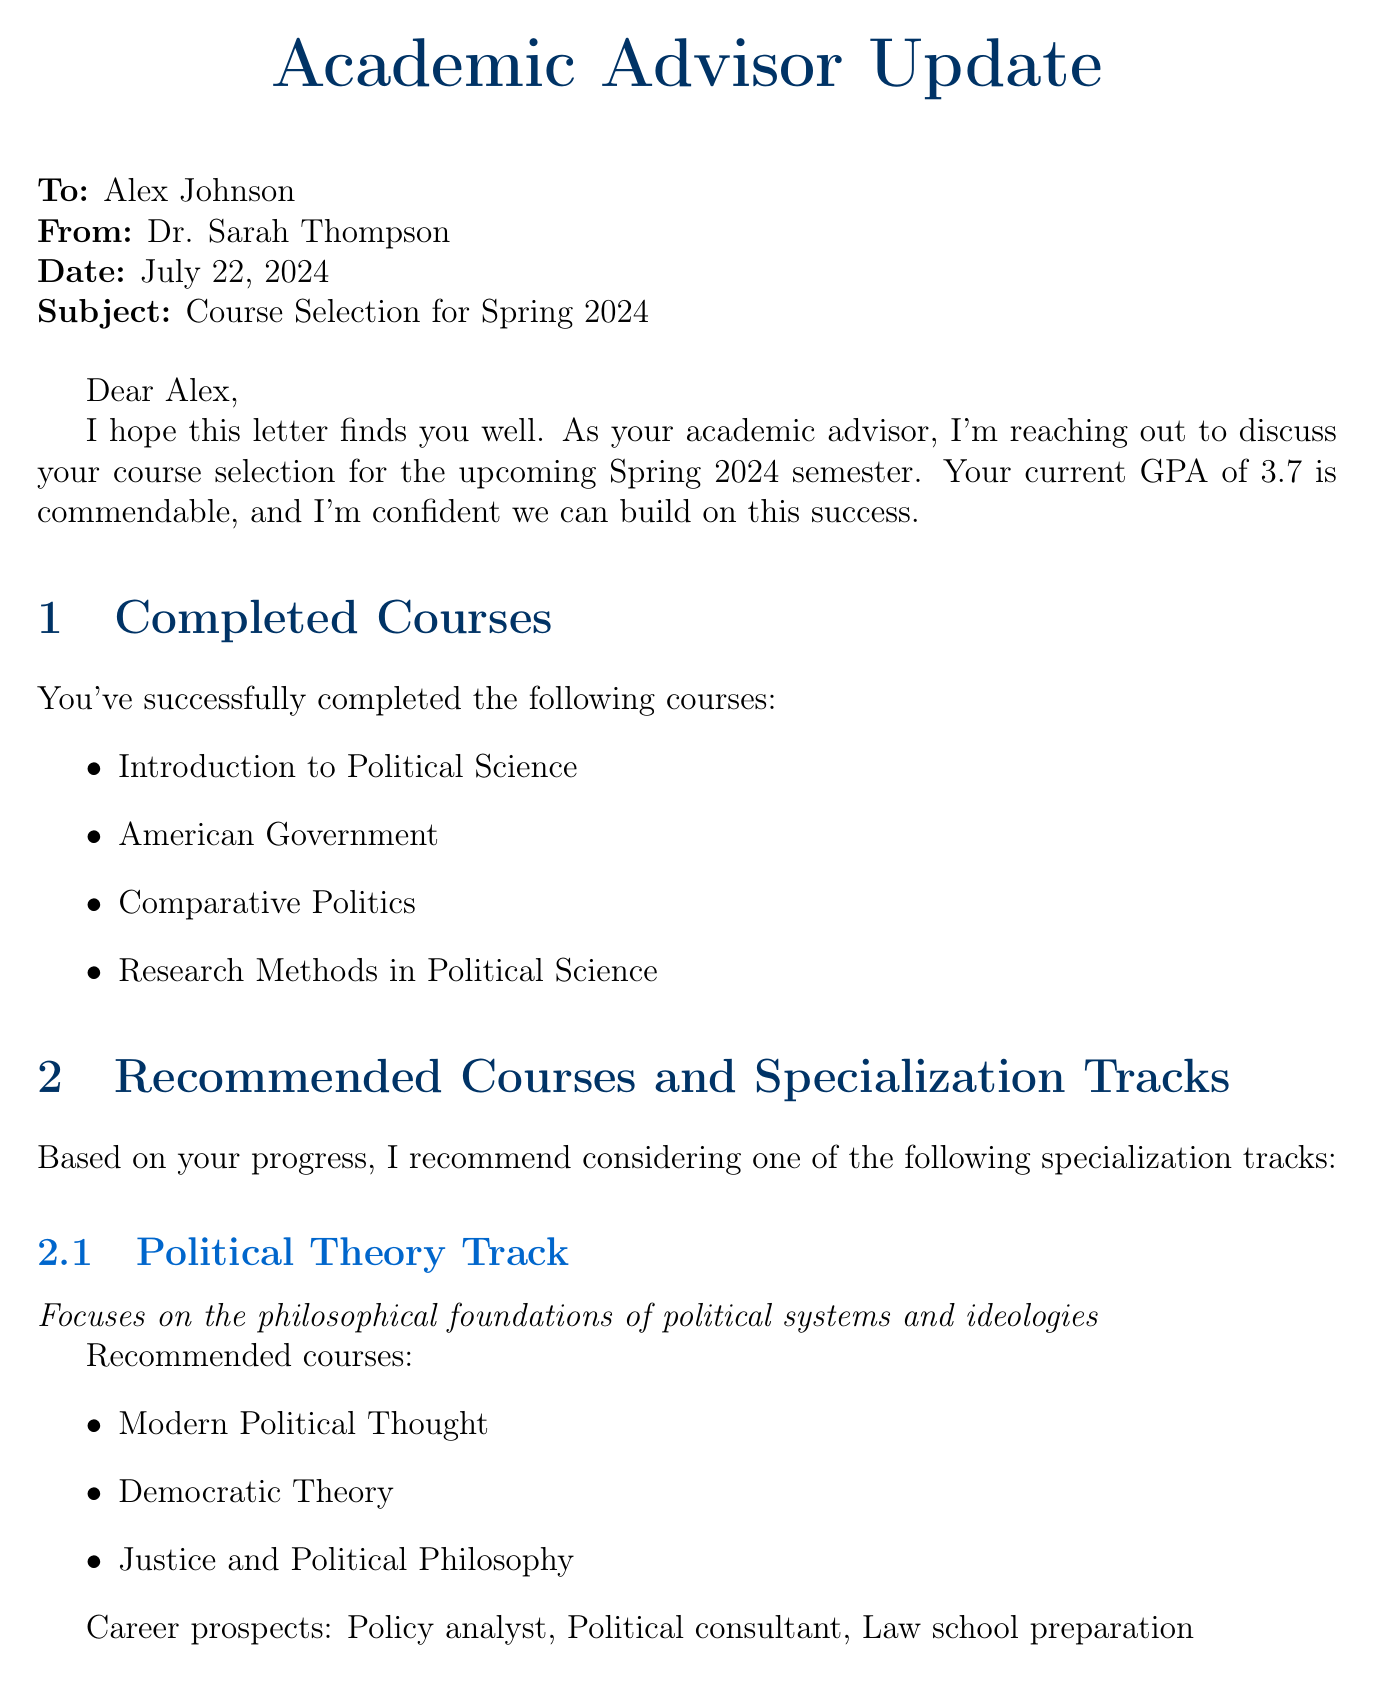What is the name of the advisor? The advisor's name is provided as Dr. Sarah Thompson in the letter.
Answer: Dr. Sarah Thompson What is Alex Johnson's current GPA? The letter mentions Alex's current GPA, which is 3.7.
Answer: 3.7 When is the Political Science Department Open House scheduled? The date for the event is explicitly stated in the document as November 15, 2023.
Answer: November 15, 2023 What are the recommended courses for the Political Theory track? The letter lists specific courses recommended for this track, which are Modern Political Thought, Democratic Theory, and Justice and Political Philosophy.
Answer: Modern Political Thought, Democratic Theory, Justice and Political Philosophy What are the career prospects for studying International Relations? The letter outlines potential career paths for this track, including Diplomat, International NGO worker, and Intelligence analyst.
Answer: Diplomat, International NGO worker, Intelligence analyst What time are the advisor's office hours? The office hours are specified in the document as from 2:00 PM to 4:00 PM on Tuesdays and Thursdays.
Answer: 2:00 PM - 4:00 PM What internship opportunity has a deadline of February 1, 2024? The internship mentioned with this deadline is with the United States Congress for the position of Congressional Intern.
Answer: Congressional Intern Which study abroad program lasts for one semester? The program that is described as lasting one semester is the London School of Economics and Political Science.
Answer: London School of Economics and Political Science What is the location of the Guest Lecture by Dr. Francis Fukuyama? The document states that the venue for the guest lecture is the Lincoln Auditorium.
Answer: Lincoln Auditorium 